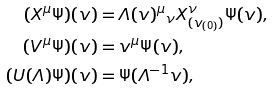Convert formula to latex. <formula><loc_0><loc_0><loc_500><loc_500>( X ^ { \mu } \Psi ) ( v ) & = { \varLambda ( v ) ^ { \mu } } _ { \nu } X ^ { \nu } _ { ( { { v _ { ( 0 ) } } } ) } \Psi ( v ) , \\ ( V ^ { \mu } \Psi ) ( v ) & = v ^ { \mu } \Psi ( v ) , \\ ( U ( \varLambda ) \Psi ) ( v ) & = \Psi ( \varLambda ^ { - 1 } v ) ,</formula> 